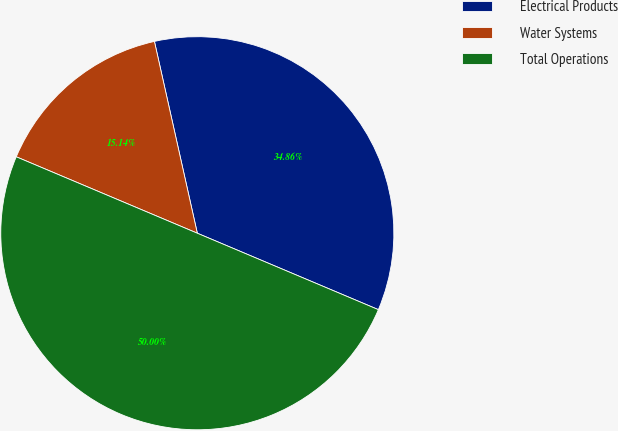Convert chart to OTSL. <chart><loc_0><loc_0><loc_500><loc_500><pie_chart><fcel>Electrical Products<fcel>Water Systems<fcel>Total Operations<nl><fcel>34.86%<fcel>15.14%<fcel>50.0%<nl></chart> 